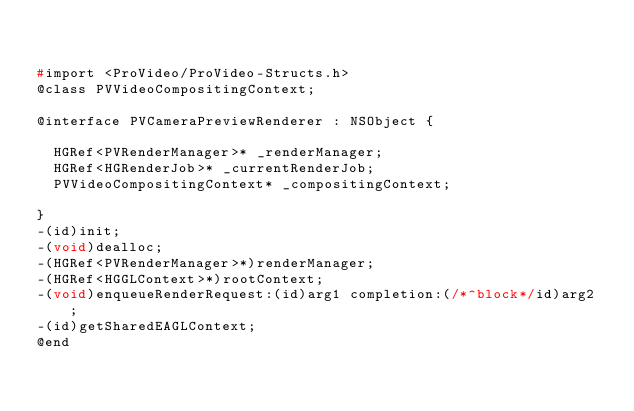<code> <loc_0><loc_0><loc_500><loc_500><_C_>

#import <ProVideo/ProVideo-Structs.h>
@class PVVideoCompositingContext;

@interface PVCameraPreviewRenderer : NSObject {

	HGRef<PVRenderManager>* _renderManager;
	HGRef<HGRenderJob>* _currentRenderJob;
	PVVideoCompositingContext* _compositingContext;

}
-(id)init;
-(void)dealloc;
-(HGRef<PVRenderManager>*)renderManager;
-(HGRef<HGGLContext>*)rootContext;
-(void)enqueueRenderRequest:(id)arg1 completion:(/*^block*/id)arg2 ;
-(id)getSharedEAGLContext;
@end

</code> 